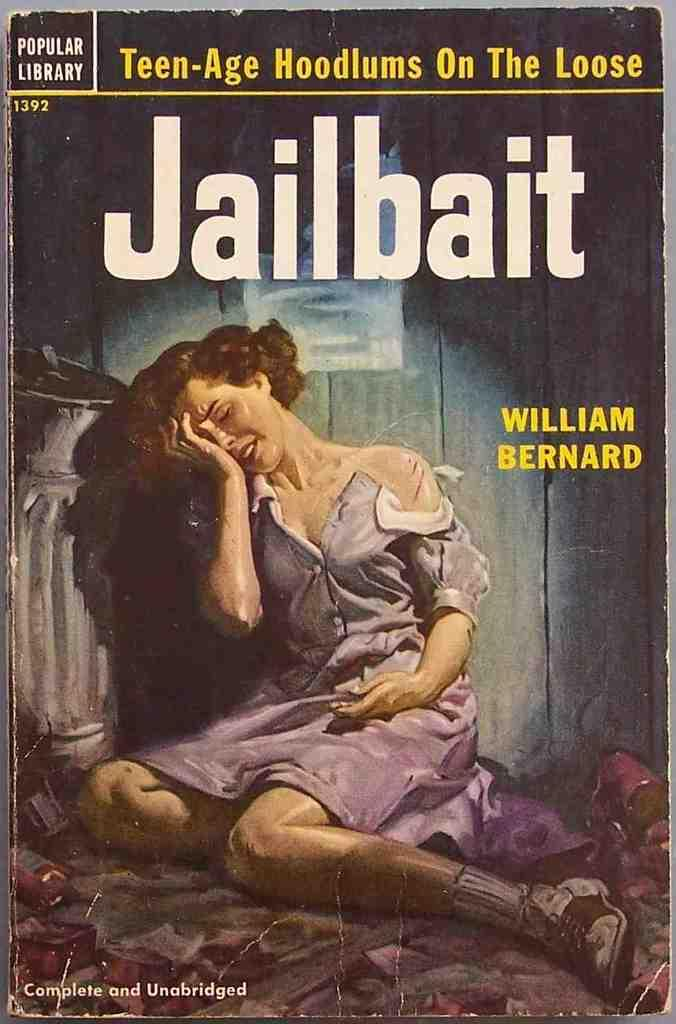Provide a one-sentence caption for the provided image. A book with a woman crying on the front titled Jailbait. 